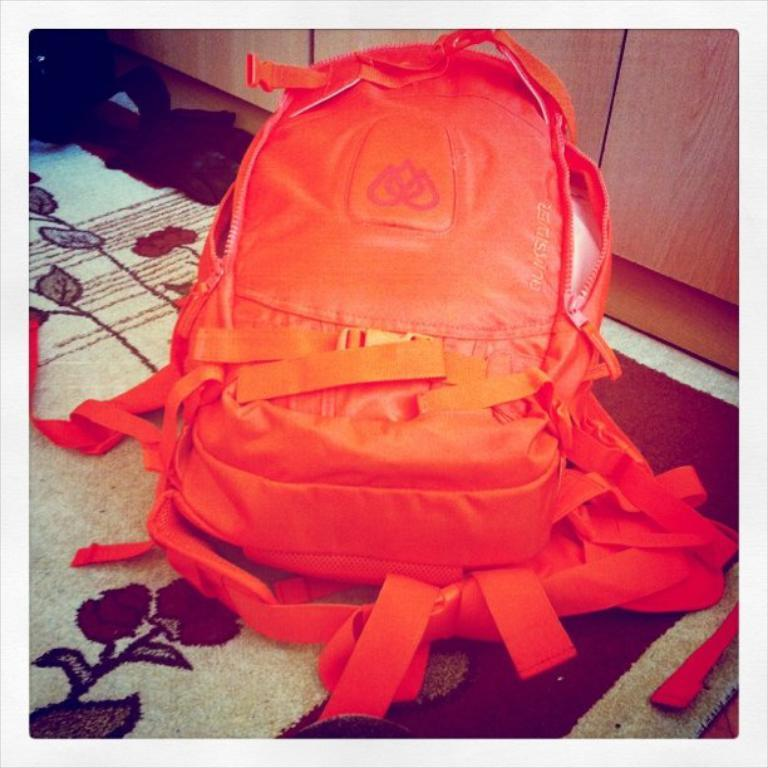What object is present in the image? There is a backpack in the image. What might the backpack be used for? The backpack might be used for carrying personal belongings or items. Can you describe the appearance of the backpack? The image only shows a backpack, so it is not possible to describe its appearance in detail. How does the backpack exhibit fear in the image? The backpack does not exhibit fear in the image, as it is an inanimate object and cannot experience emotions. 